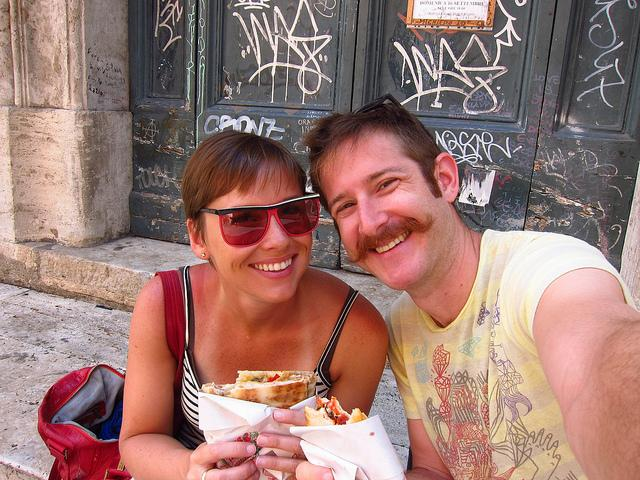Why is she covering her eyes? Please explain your reasoning. sun protection. She is wearing sunglasses. 